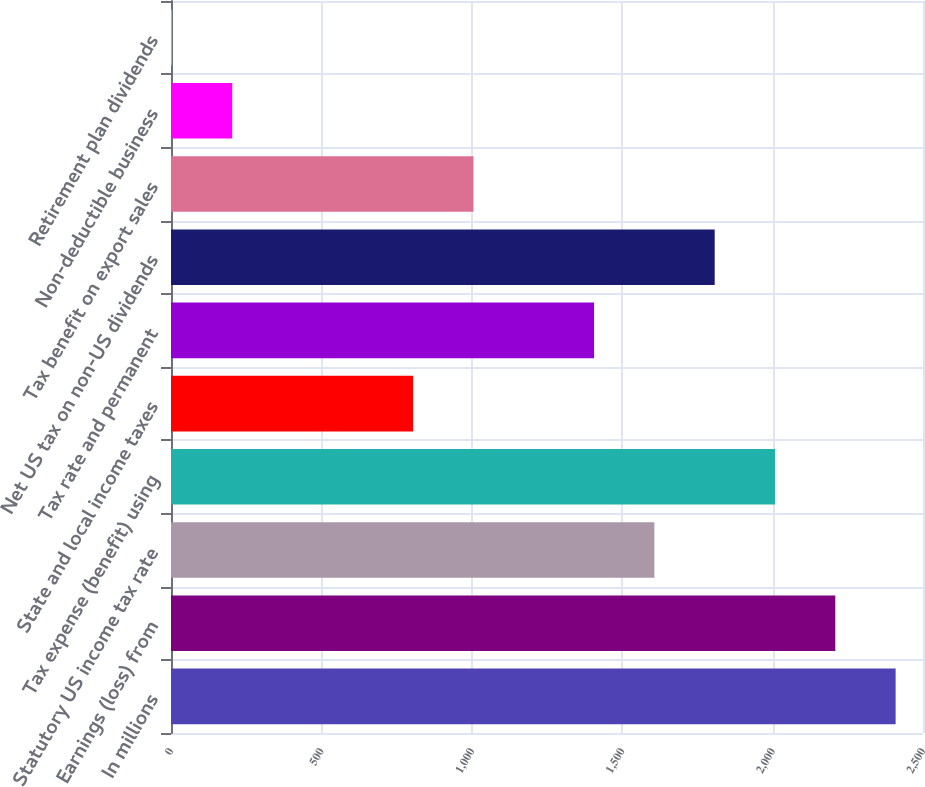Convert chart to OTSL. <chart><loc_0><loc_0><loc_500><loc_500><bar_chart><fcel>In millions<fcel>Earnings (loss) from<fcel>Statutory US income tax rate<fcel>Tax expense (benefit) using<fcel>State and local income taxes<fcel>Tax rate and permanent<fcel>Net US tax on non-US dividends<fcel>Tax benefit on export sales<fcel>Non-deductible business<fcel>Retirement plan dividends<nl><fcel>2409<fcel>2208.5<fcel>1607<fcel>2008<fcel>805<fcel>1406.5<fcel>1807.5<fcel>1005.5<fcel>203.5<fcel>3<nl></chart> 